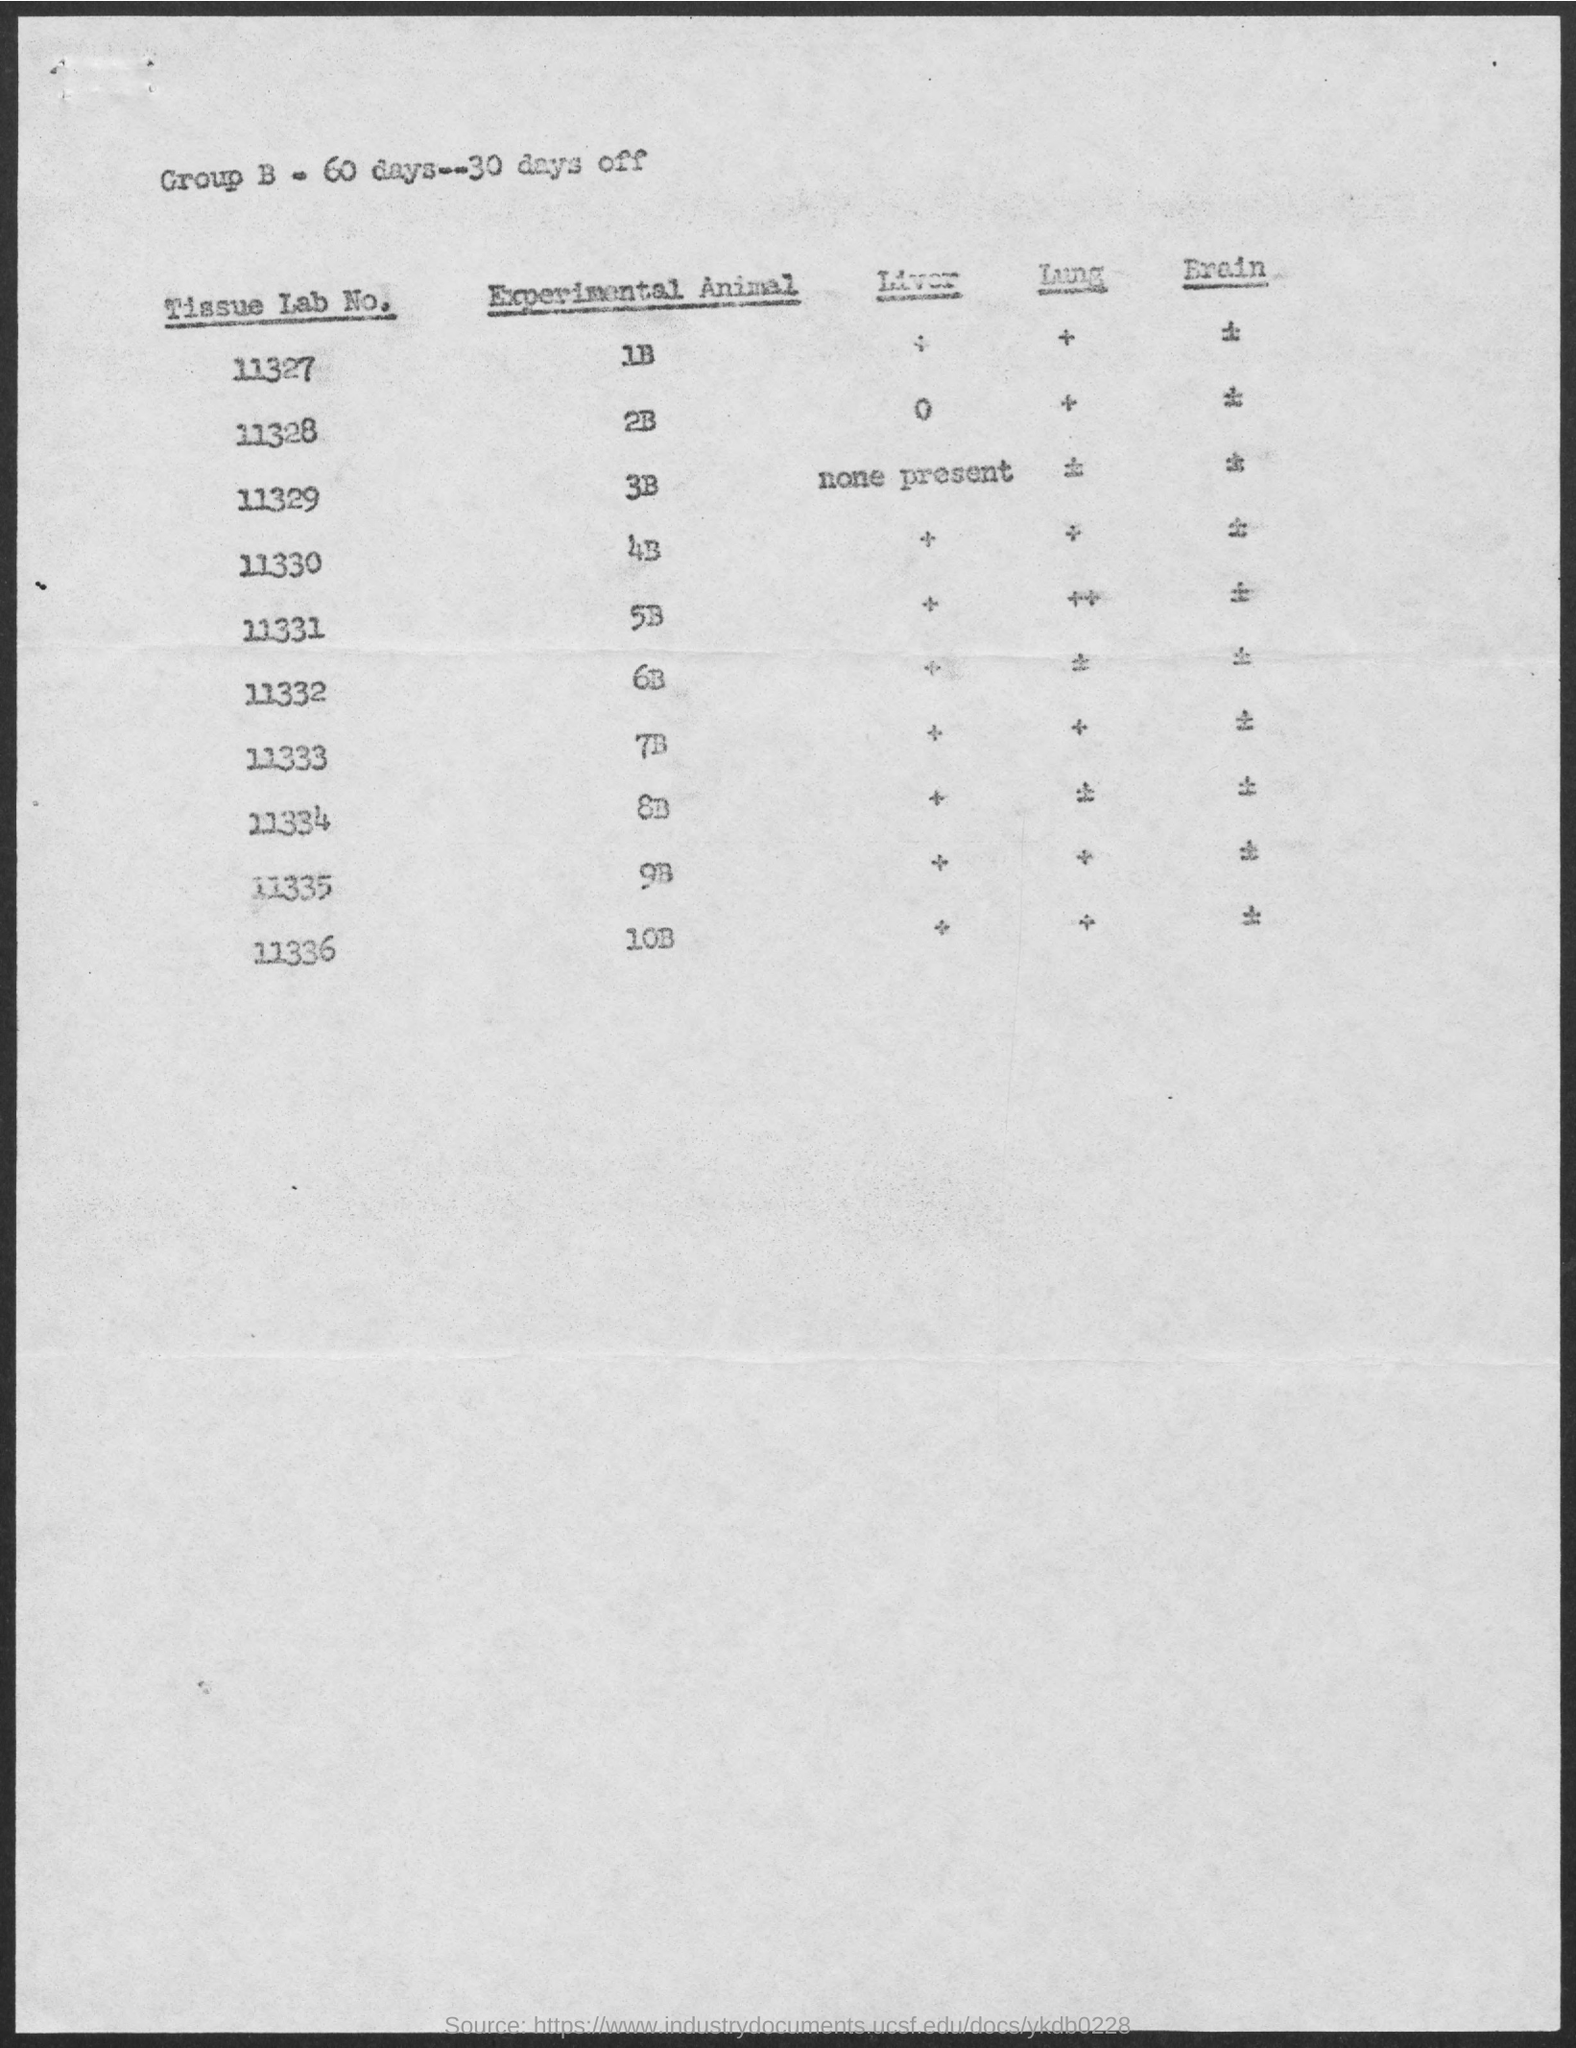Identify some key points in this picture. Group B will have 60 days. 